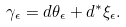<formula> <loc_0><loc_0><loc_500><loc_500>\gamma _ { \epsilon } = d \theta _ { \epsilon } + d ^ { * } \xi _ { \epsilon } .</formula> 